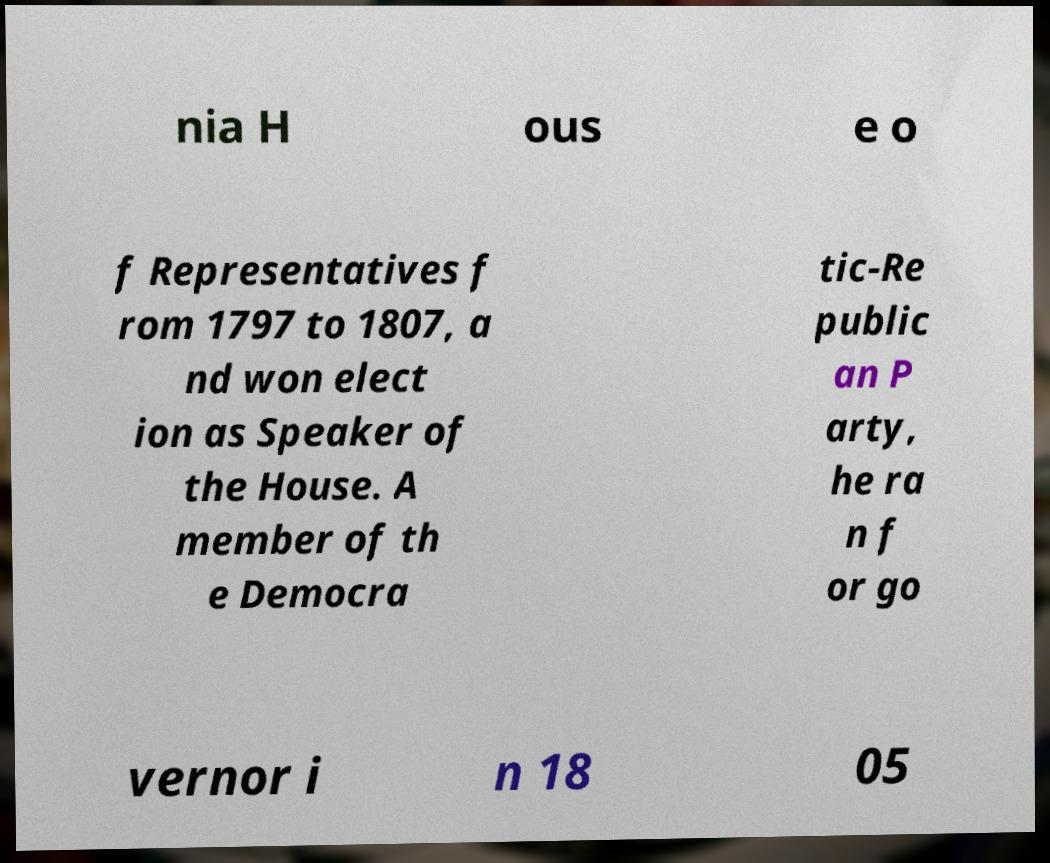For documentation purposes, I need the text within this image transcribed. Could you provide that? nia H ous e o f Representatives f rom 1797 to 1807, a nd won elect ion as Speaker of the House. A member of th e Democra tic-Re public an P arty, he ra n f or go vernor i n 18 05 